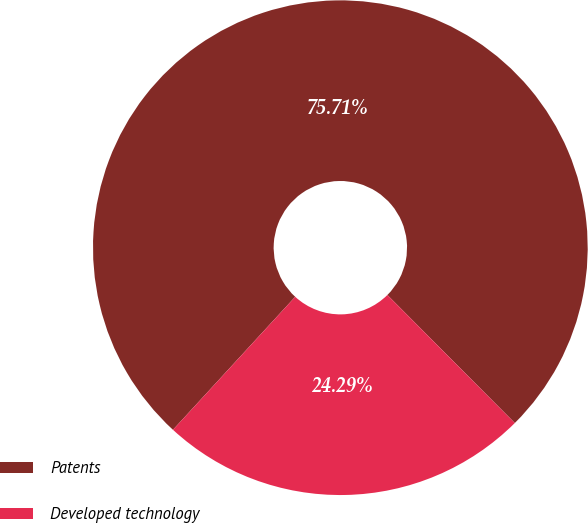<chart> <loc_0><loc_0><loc_500><loc_500><pie_chart><fcel>Patents<fcel>Developed technology<nl><fcel>75.71%<fcel>24.29%<nl></chart> 